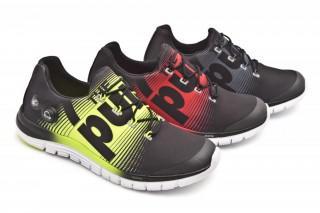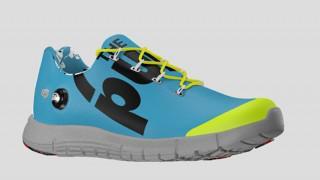The first image is the image on the left, the second image is the image on the right. Examine the images to the left and right. Is the description "A total of four sneakers are shown in the images." accurate? Answer yes or no. Yes. The first image is the image on the left, the second image is the image on the right. For the images shown, is this caption "There is at least one blue sneaker" true? Answer yes or no. Yes. 